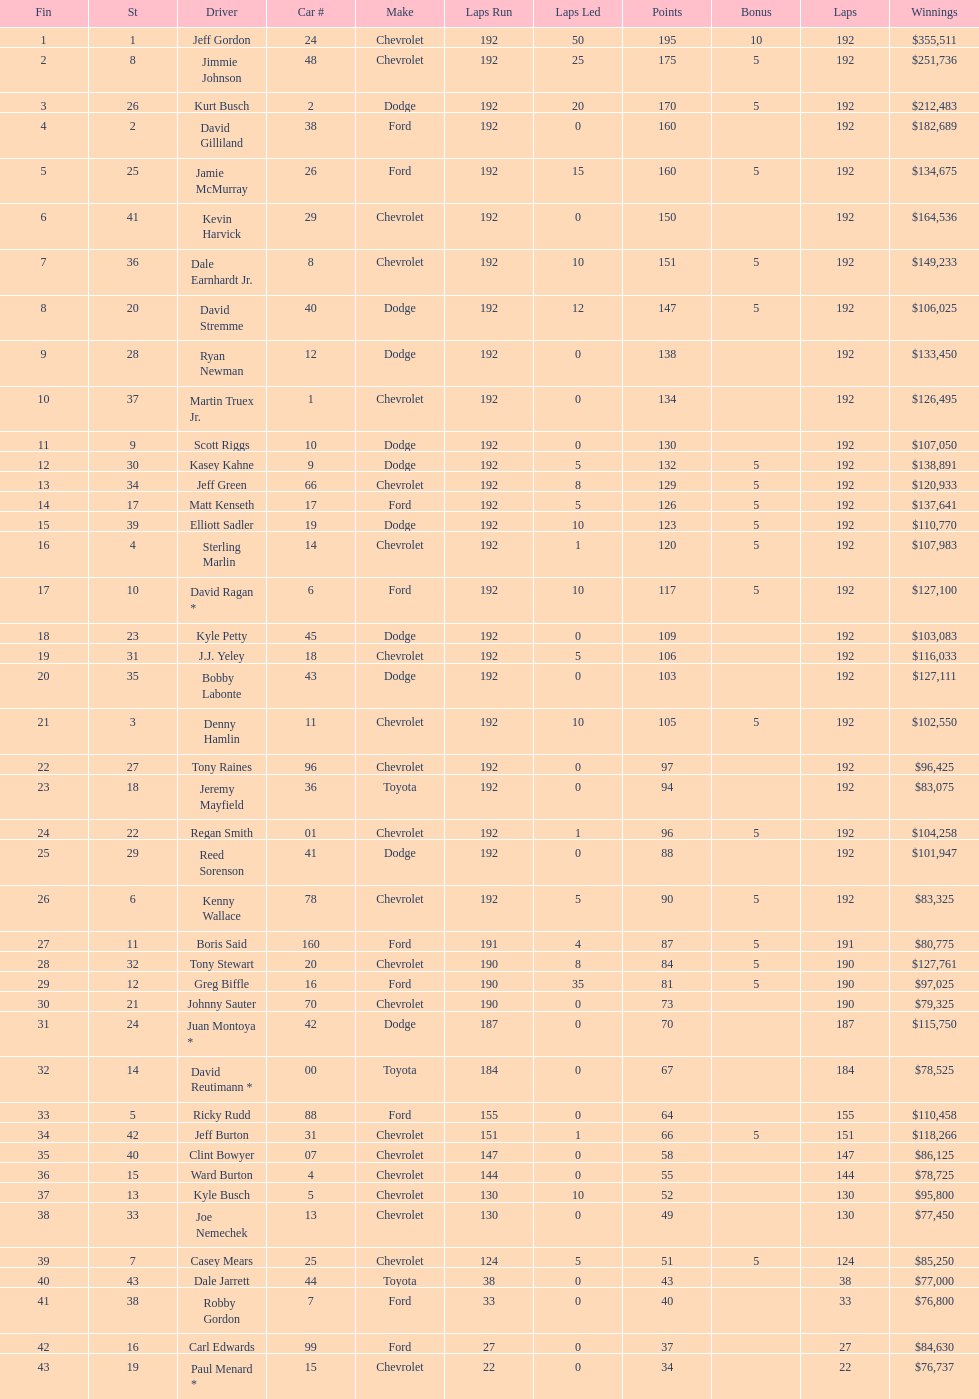What make did kurt busch drive? Dodge. 